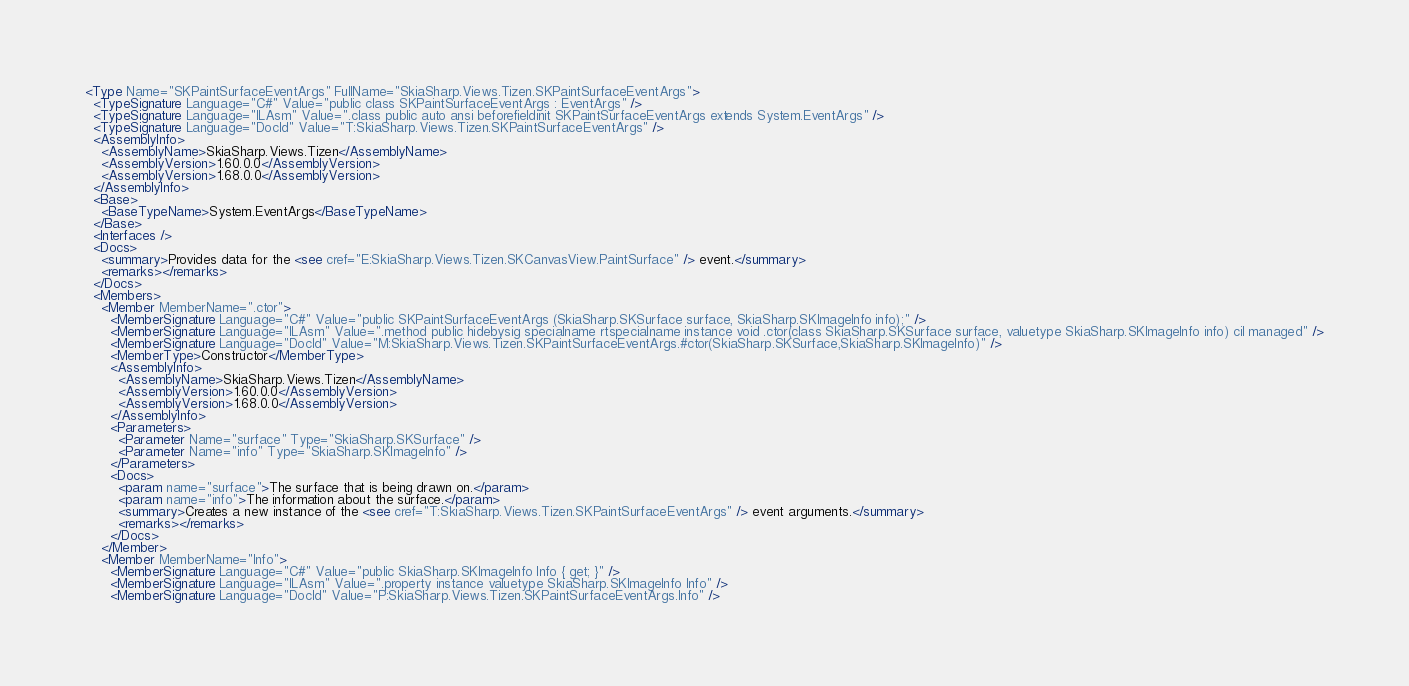Convert code to text. <code><loc_0><loc_0><loc_500><loc_500><_XML_><Type Name="SKPaintSurfaceEventArgs" FullName="SkiaSharp.Views.Tizen.SKPaintSurfaceEventArgs">
  <TypeSignature Language="C#" Value="public class SKPaintSurfaceEventArgs : EventArgs" />
  <TypeSignature Language="ILAsm" Value=".class public auto ansi beforefieldinit SKPaintSurfaceEventArgs extends System.EventArgs" />
  <TypeSignature Language="DocId" Value="T:SkiaSharp.Views.Tizen.SKPaintSurfaceEventArgs" />
  <AssemblyInfo>
    <AssemblyName>SkiaSharp.Views.Tizen</AssemblyName>
    <AssemblyVersion>1.60.0.0</AssemblyVersion>
    <AssemblyVersion>1.68.0.0</AssemblyVersion>
  </AssemblyInfo>
  <Base>
    <BaseTypeName>System.EventArgs</BaseTypeName>
  </Base>
  <Interfaces />
  <Docs>
    <summary>Provides data for the <see cref="E:SkiaSharp.Views.Tizen.SKCanvasView.PaintSurface" /> event.</summary>
    <remarks></remarks>
  </Docs>
  <Members>
    <Member MemberName=".ctor">
      <MemberSignature Language="C#" Value="public SKPaintSurfaceEventArgs (SkiaSharp.SKSurface surface, SkiaSharp.SKImageInfo info);" />
      <MemberSignature Language="ILAsm" Value=".method public hidebysig specialname rtspecialname instance void .ctor(class SkiaSharp.SKSurface surface, valuetype SkiaSharp.SKImageInfo info) cil managed" />
      <MemberSignature Language="DocId" Value="M:SkiaSharp.Views.Tizen.SKPaintSurfaceEventArgs.#ctor(SkiaSharp.SKSurface,SkiaSharp.SKImageInfo)" />
      <MemberType>Constructor</MemberType>
      <AssemblyInfo>
        <AssemblyName>SkiaSharp.Views.Tizen</AssemblyName>
        <AssemblyVersion>1.60.0.0</AssemblyVersion>
        <AssemblyVersion>1.68.0.0</AssemblyVersion>
      </AssemblyInfo>
      <Parameters>
        <Parameter Name="surface" Type="SkiaSharp.SKSurface" />
        <Parameter Name="info" Type="SkiaSharp.SKImageInfo" />
      </Parameters>
      <Docs>
        <param name="surface">The surface that is being drawn on.</param>
        <param name="info">The information about the surface.</param>
        <summary>Creates a new instance of the <see cref="T:SkiaSharp.Views.Tizen.SKPaintSurfaceEventArgs" /> event arguments.</summary>
        <remarks></remarks>
      </Docs>
    </Member>
    <Member MemberName="Info">
      <MemberSignature Language="C#" Value="public SkiaSharp.SKImageInfo Info { get; }" />
      <MemberSignature Language="ILAsm" Value=".property instance valuetype SkiaSharp.SKImageInfo Info" />
      <MemberSignature Language="DocId" Value="P:SkiaSharp.Views.Tizen.SKPaintSurfaceEventArgs.Info" /></code> 